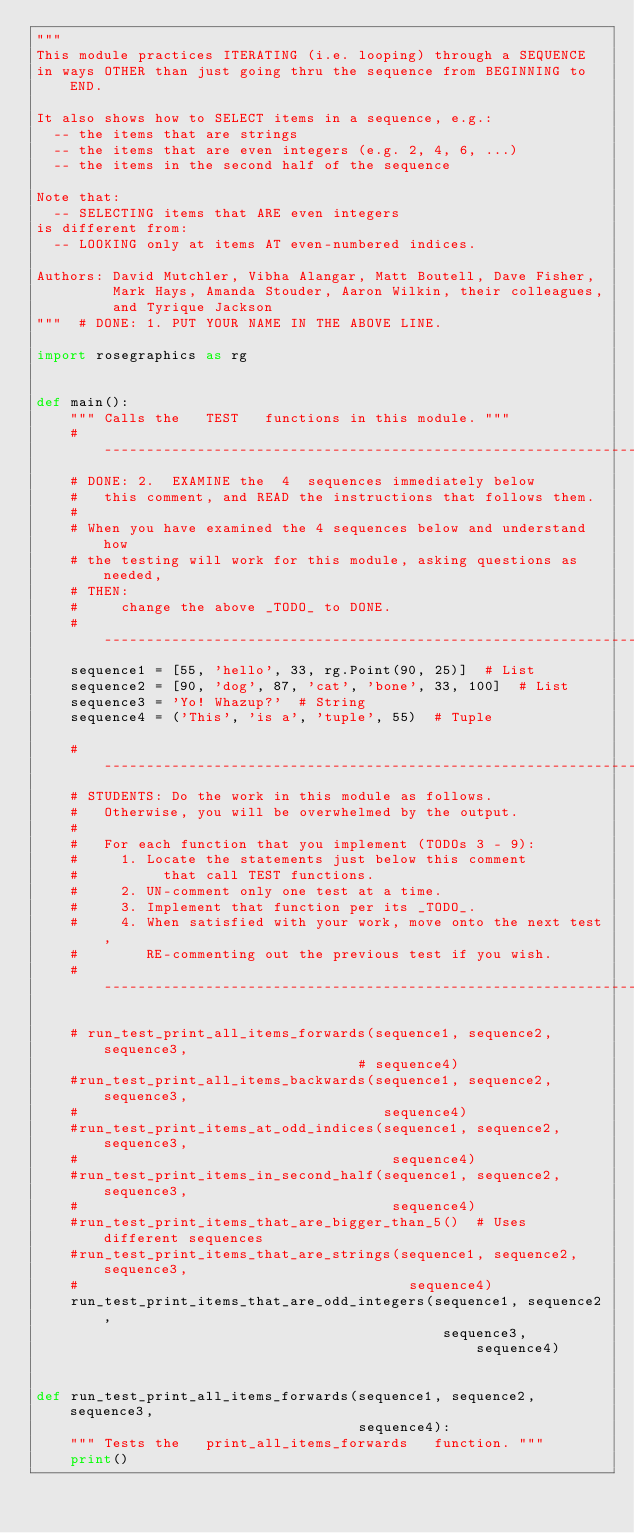<code> <loc_0><loc_0><loc_500><loc_500><_Python_>"""
This module practices ITERATING (i.e. looping) through a SEQUENCE
in ways OTHER than just going thru the sequence from BEGINNING to END.

It also shows how to SELECT items in a sequence, e.g.:
  -- the items that are strings
  -- the items that are even integers (e.g. 2, 4, 6, ...)
  -- the items in the second half of the sequence

Note that:
  -- SELECTING items that ARE even integers
is different from:
  -- LOOKING only at items AT even-numbered indices.

Authors: David Mutchler, Vibha Alangar, Matt Boutell, Dave Fisher,
         Mark Hays, Amanda Stouder, Aaron Wilkin, their colleagues,
         and Tyrique Jackson
"""  # DONE: 1. PUT YOUR NAME IN THE ABOVE LINE.

import rosegraphics as rg


def main():
    """ Calls the   TEST   functions in this module. """
    # -------------------------------------------------------------------------
    # DONE: 2.  EXAMINE the  4  sequences immediately below
    #   this comment, and READ the instructions that follows them.
    #
    # When you have examined the 4 sequences below and understand how
    # the testing will work for this module, asking questions as needed,
    # THEN:
    #     change the above _TODO_ to DONE.
    # -------------------------------------------------------------------------
    sequence1 = [55, 'hello', 33, rg.Point(90, 25)]  # List
    sequence2 = [90, 'dog', 87, 'cat', 'bone', 33, 100]  # List
    sequence3 = 'Yo! Whazup?'  # String
    sequence4 = ('This', 'is a', 'tuple', 55)  # Tuple

    # -------------------------------------------------------------------------
    # STUDENTS: Do the work in this module as follows.
    #   Otherwise, you will be overwhelmed by the output.
    #
    #   For each function that you implement (TODOs 3 - 9):
    #     1. Locate the statements just below this comment
    #          that call TEST functions.
    #     2. UN-comment only one test at a time.
    #     3. Implement that function per its _TODO_.
    #     4. When satisfied with your work, move onto the next test,
    #        RE-commenting out the previous test if you wish.
    # -------------------------------------------------------------------------

    # run_test_print_all_items_forwards(sequence1, sequence2, sequence3,
                                      # sequence4)
    #run_test_print_all_items_backwards(sequence1, sequence2, sequence3,
    #                                    sequence4)
    #run_test_print_items_at_odd_indices(sequence1, sequence2, sequence3,
    #                                     sequence4)
    #run_test_print_items_in_second_half(sequence1, sequence2, sequence3,
    #                                     sequence4)
    #run_test_print_items_that_are_bigger_than_5()  # Uses different sequences
    #run_test_print_items_that_are_strings(sequence1, sequence2, sequence3,
    #                                       sequence4)
    run_test_print_items_that_are_odd_integers(sequence1, sequence2,
                                                sequence3, sequence4)


def run_test_print_all_items_forwards(sequence1, sequence2, sequence3,
                                      sequence4):
    """ Tests the   print_all_items_forwards   function. """
    print()</code> 